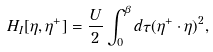Convert formula to latex. <formula><loc_0><loc_0><loc_500><loc_500>H _ { I } [ \eta , \eta ^ { + } ] = \frac { U } { 2 } \int _ { 0 } ^ { \beta } d \tau ( \eta ^ { + } \cdot \eta ) ^ { 2 } ,</formula> 